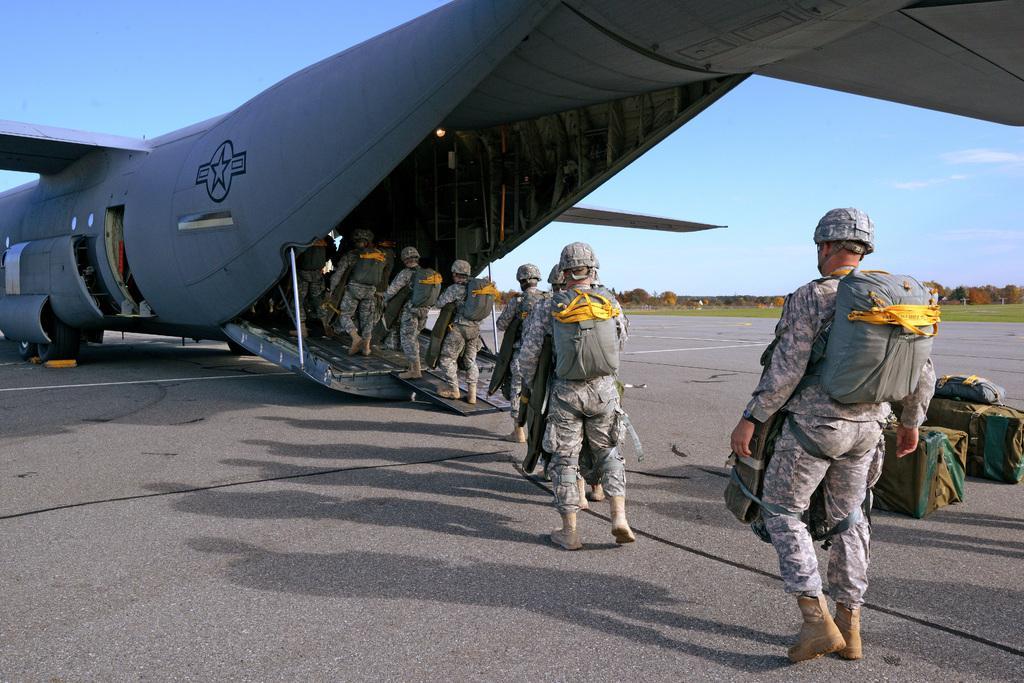Describe this image in one or two sentences. In this image I can see group of people and they are wearing military uniforms. I can also see few persons entering into an aircraft, background I can see trees in green color and sky in blue color. 